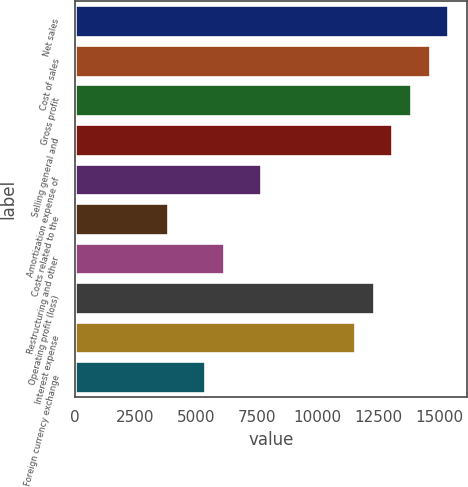Convert chart. <chart><loc_0><loc_0><loc_500><loc_500><bar_chart><fcel>Net sales<fcel>Cost of sales<fcel>Gross profit<fcel>Selling general and<fcel>Amortization expense of<fcel>Costs related to the<fcel>Restructuring and other<fcel>Operating profit (loss)<fcel>Interest expense<fcel>Foreign currency exchange<nl><fcel>15381.4<fcel>14612.3<fcel>13843.2<fcel>13074.2<fcel>7690.76<fcel>3845.46<fcel>6152.64<fcel>12305.1<fcel>11536.1<fcel>5383.58<nl></chart> 